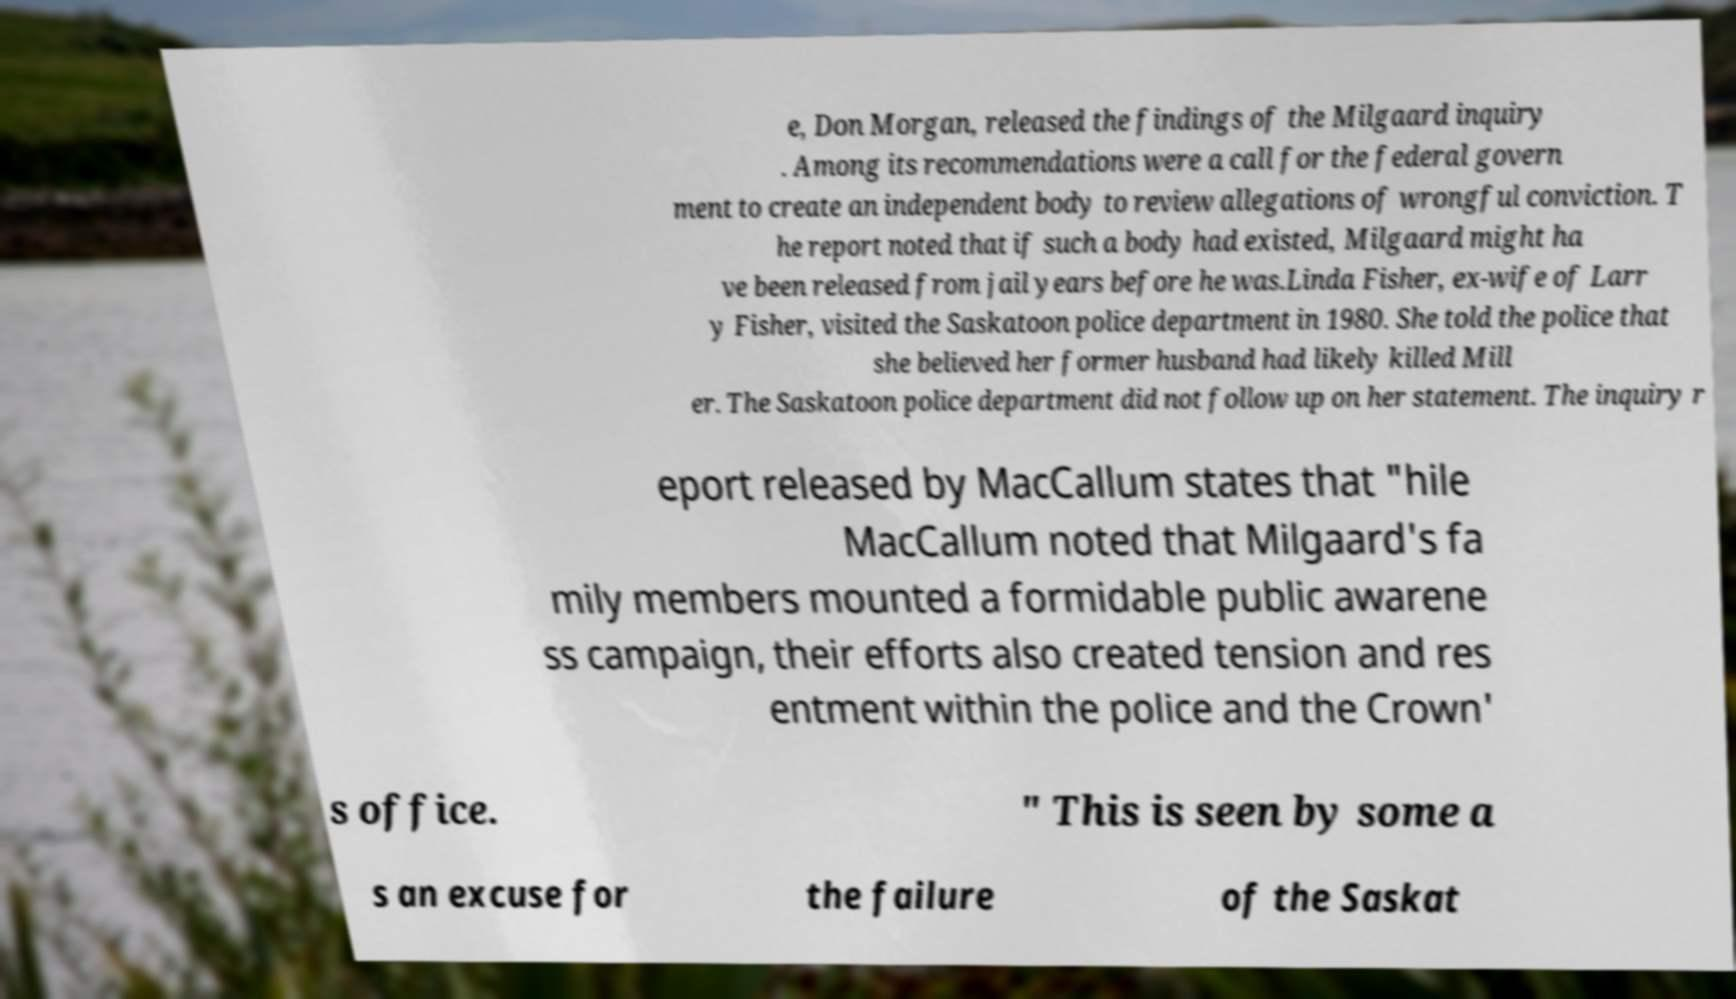Can you read and provide the text displayed in the image?This photo seems to have some interesting text. Can you extract and type it out for me? e, Don Morgan, released the findings of the Milgaard inquiry . Among its recommendations were a call for the federal govern ment to create an independent body to review allegations of wrongful conviction. T he report noted that if such a body had existed, Milgaard might ha ve been released from jail years before he was.Linda Fisher, ex-wife of Larr y Fisher, visited the Saskatoon police department in 1980. She told the police that she believed her former husband had likely killed Mill er. The Saskatoon police department did not follow up on her statement. The inquiry r eport released by MacCallum states that "hile MacCallum noted that Milgaard's fa mily members mounted a formidable public awarene ss campaign, their efforts also created tension and res entment within the police and the Crown' s office. " This is seen by some a s an excuse for the failure of the Saskat 